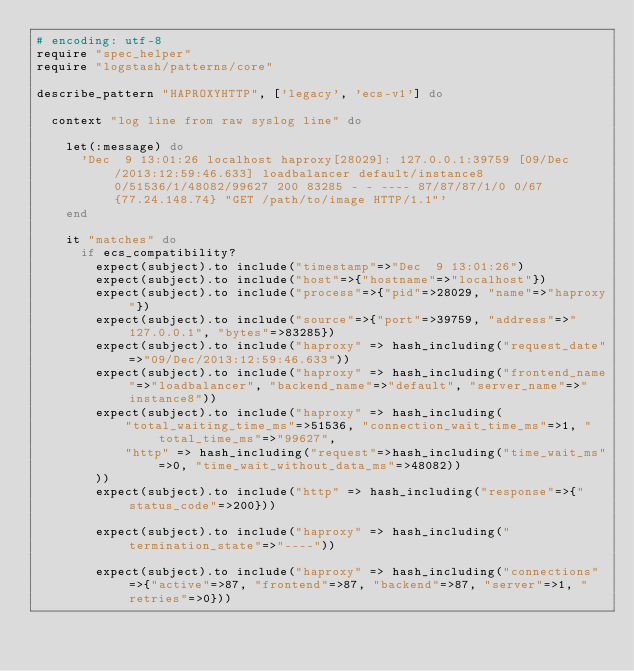<code> <loc_0><loc_0><loc_500><loc_500><_Ruby_># encoding: utf-8
require "spec_helper"
require "logstash/patterns/core"

describe_pattern "HAPROXYHTTP", ['legacy', 'ecs-v1'] do

  context "log line from raw syslog line" do

    let(:message) do
      'Dec  9 13:01:26 localhost haproxy[28029]: 127.0.0.1:39759 [09/Dec/2013:12:59:46.633] loadbalancer default/instance8 0/51536/1/48082/99627 200 83285 - - ---- 87/87/87/1/0 0/67 {77.24.148.74} "GET /path/to/image HTTP/1.1"'
    end

    it "matches" do
      if ecs_compatibility?
        expect(subject).to include("timestamp"=>"Dec  9 13:01:26")
        expect(subject).to include("host"=>{"hostname"=>"localhost"})
        expect(subject).to include("process"=>{"pid"=>28029, "name"=>"haproxy"})
        expect(subject).to include("source"=>{"port"=>39759, "address"=>"127.0.0.1", "bytes"=>83285})
        expect(subject).to include("haproxy" => hash_including("request_date"=>"09/Dec/2013:12:59:46.633"))
        expect(subject).to include("haproxy" => hash_including("frontend_name"=>"loadbalancer", "backend_name"=>"default", "server_name"=>"instance8"))
        expect(subject).to include("haproxy" => hash_including(
            "total_waiting_time_ms"=>51536, "connection_wait_time_ms"=>1, "total_time_ms"=>"99627",
            "http" => hash_including("request"=>hash_including("time_wait_ms"=>0, "time_wait_without_data_ms"=>48082))
        ))
        expect(subject).to include("http" => hash_including("response"=>{"status_code"=>200}))

        expect(subject).to include("haproxy" => hash_including("termination_state"=>"----"))

        expect(subject).to include("haproxy" => hash_including("connections"=>{"active"=>87, "frontend"=>87, "backend"=>87, "server"=>1, "retries"=>0}))</code> 